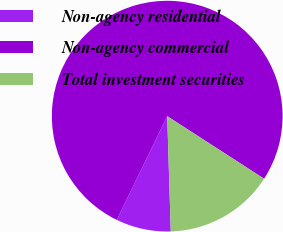Convert chart. <chart><loc_0><loc_0><loc_500><loc_500><pie_chart><fcel>Non-agency residential<fcel>Non-agency commercial<fcel>Total investment securities<nl><fcel>7.69%<fcel>76.92%<fcel>15.38%<nl></chart> 